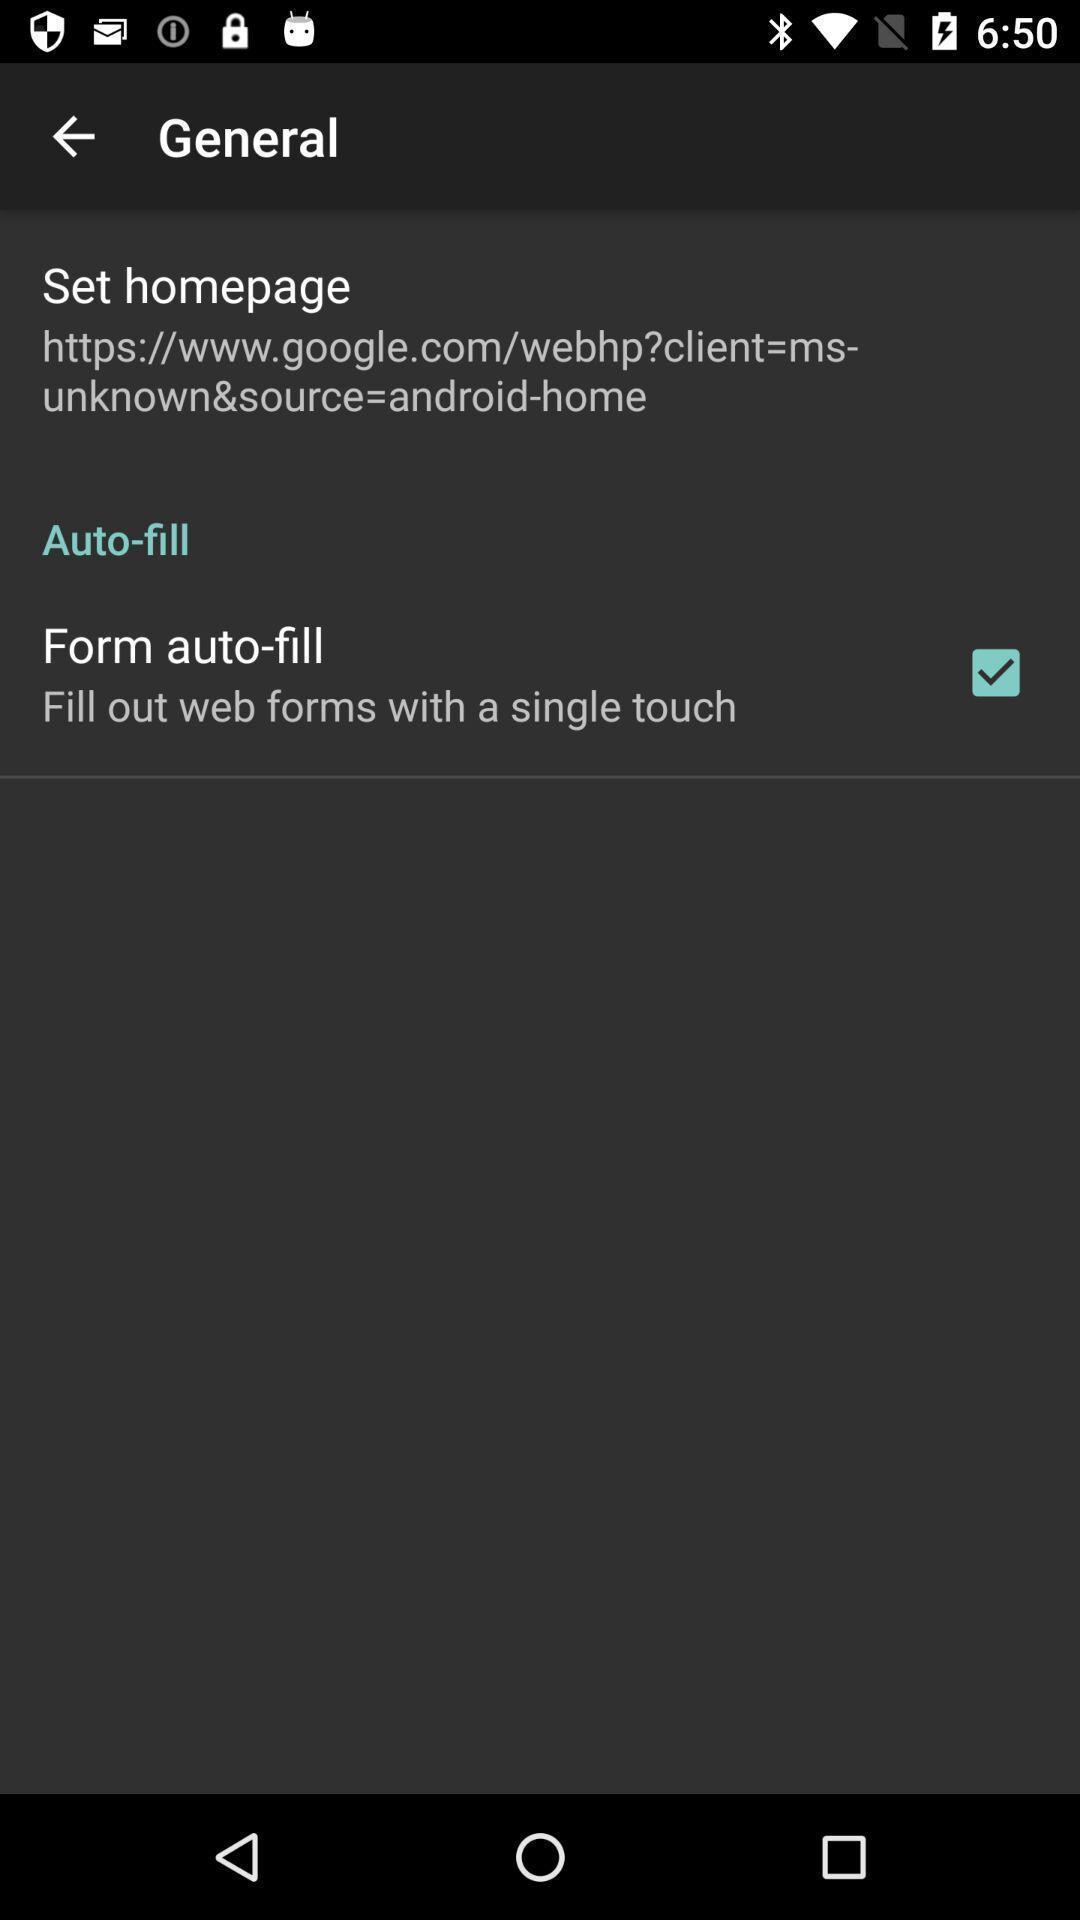Give me a summary of this screen capture. Page showing info in a cycling data tracking app. 